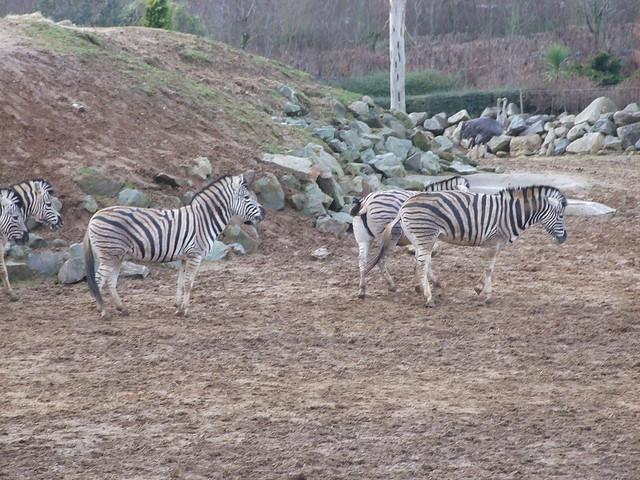How many zebras are there?
Give a very brief answer. 4. How many zebras are visible?
Give a very brief answer. 3. 